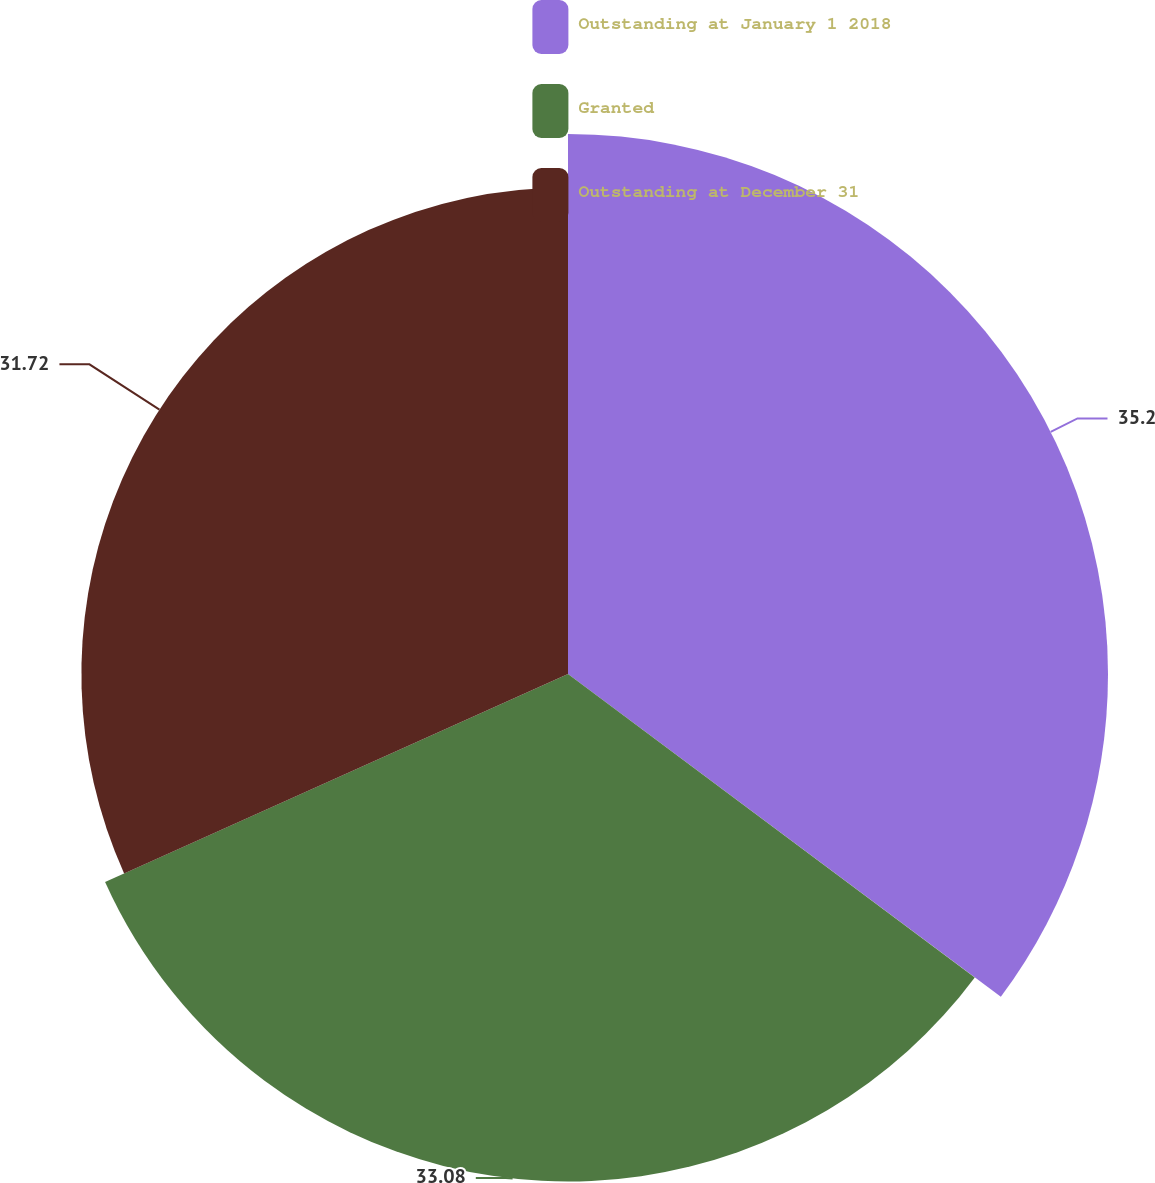Convert chart. <chart><loc_0><loc_0><loc_500><loc_500><pie_chart><fcel>Outstanding at January 1 2018<fcel>Granted<fcel>Outstanding at December 31<nl><fcel>35.2%<fcel>33.08%<fcel>31.72%<nl></chart> 